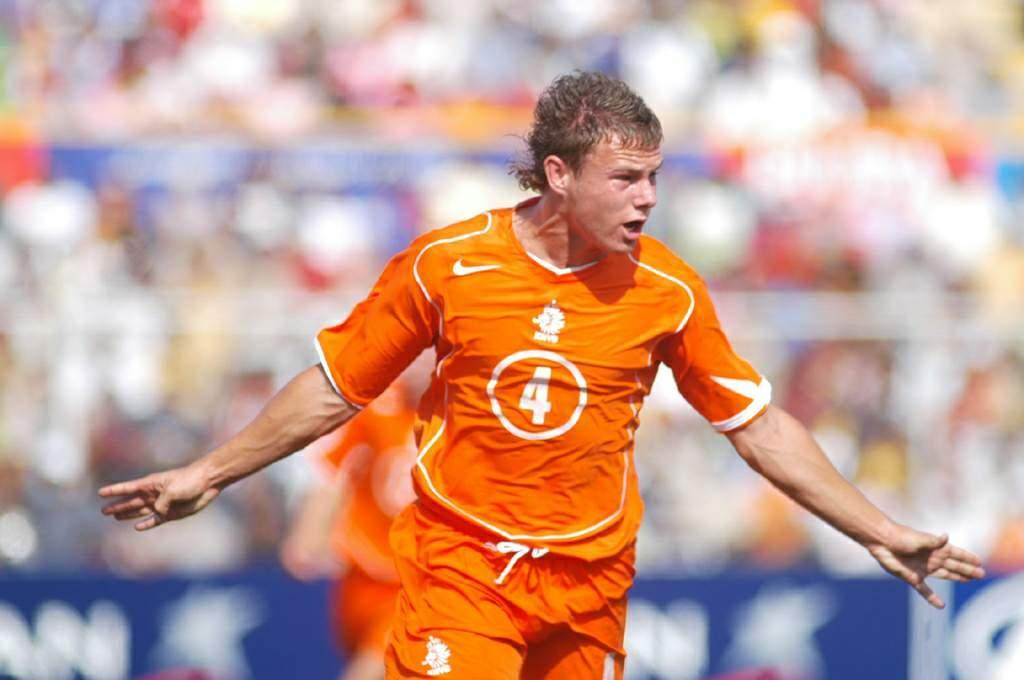Who is the main subject in the image? There is a man in the picture. What is the man wearing in the image? The man is wearing a t-shirt. Can you describe the background of the image? The background of the image is blurry. How many pies are being shared by the group in the image? There is no group or pies present in the image; it features a man wearing a t-shirt with a blurry background. 